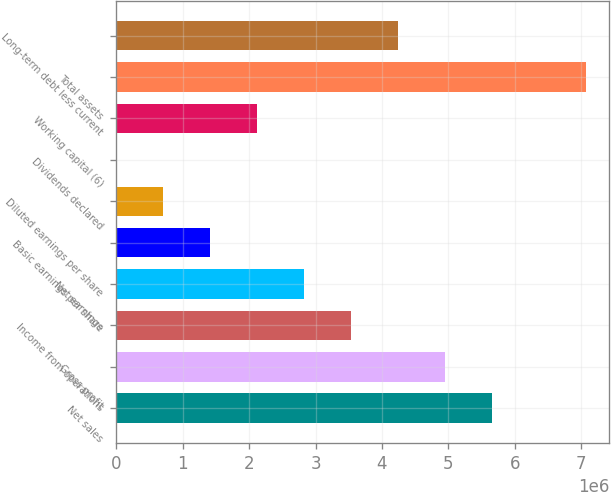Convert chart. <chart><loc_0><loc_0><loc_500><loc_500><bar_chart><fcel>Net sales<fcel>Gross profit<fcel>Income from operations<fcel>Net earnings<fcel>Basic earnings per share<fcel>Diluted earnings per share<fcel>Dividends declared<fcel>Working capital (6)<fcel>Total assets<fcel>Long-term debt less current<nl><fcel>5.65688e+06<fcel>4.94977e+06<fcel>3.53555e+06<fcel>2.82844e+06<fcel>1.41422e+06<fcel>707111<fcel>0.58<fcel>2.12133e+06<fcel>7.0711e+06<fcel>4.24266e+06<nl></chart> 